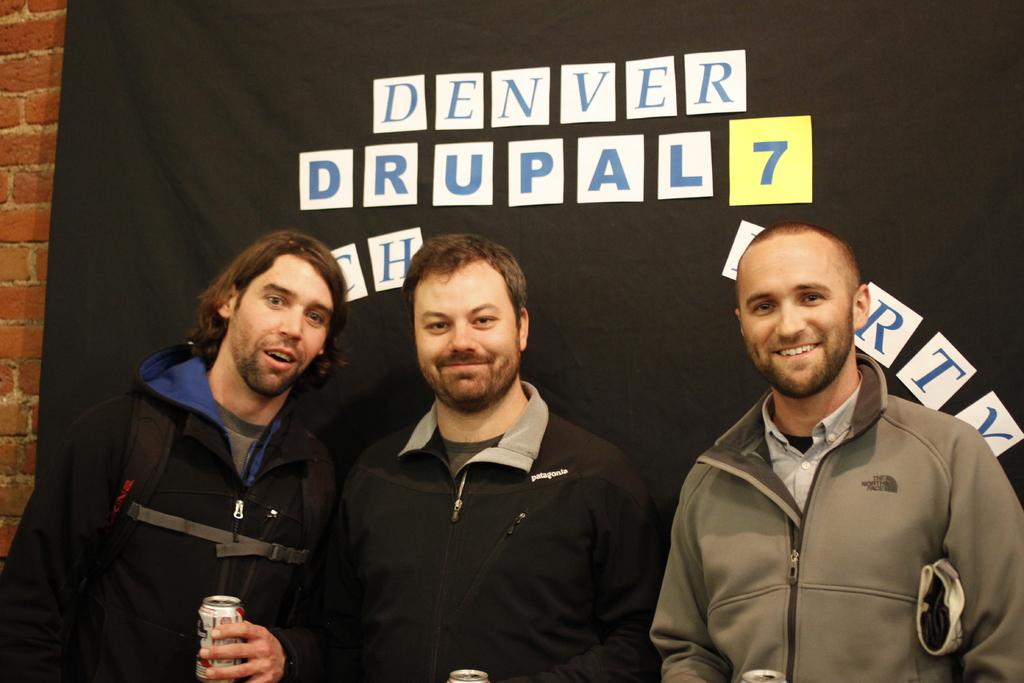What team is being advertised?
Provide a succinct answer. Denver drupal. What brand is the man's jacket on the right?
Provide a succinct answer. The north face. 